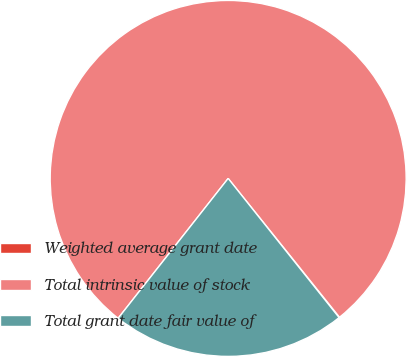Convert chart to OTSL. <chart><loc_0><loc_0><loc_500><loc_500><pie_chart><fcel>Weighted average grant date<fcel>Total intrinsic value of stock<fcel>Total grant date fair value of<nl><fcel>0.05%<fcel>78.63%<fcel>21.32%<nl></chart> 